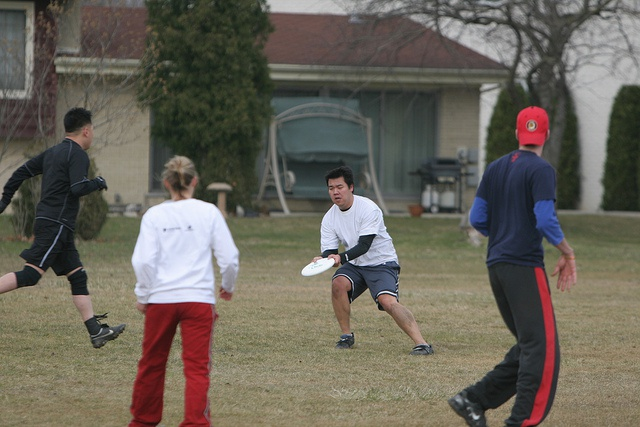Describe the objects in this image and their specific colors. I can see people in black, navy, gray, and brown tones, people in black, lavender, maroon, brown, and darkgray tones, people in black, gray, and darkgray tones, people in black, lavender, and gray tones, and bench in black, gray, and purple tones in this image. 